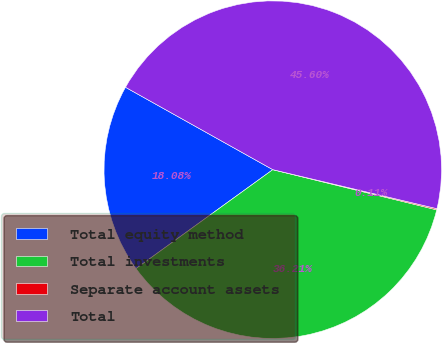Convert chart. <chart><loc_0><loc_0><loc_500><loc_500><pie_chart><fcel>Total equity method<fcel>Total investments<fcel>Separate account assets<fcel>Total<nl><fcel>18.08%<fcel>36.21%<fcel>0.11%<fcel>45.6%<nl></chart> 